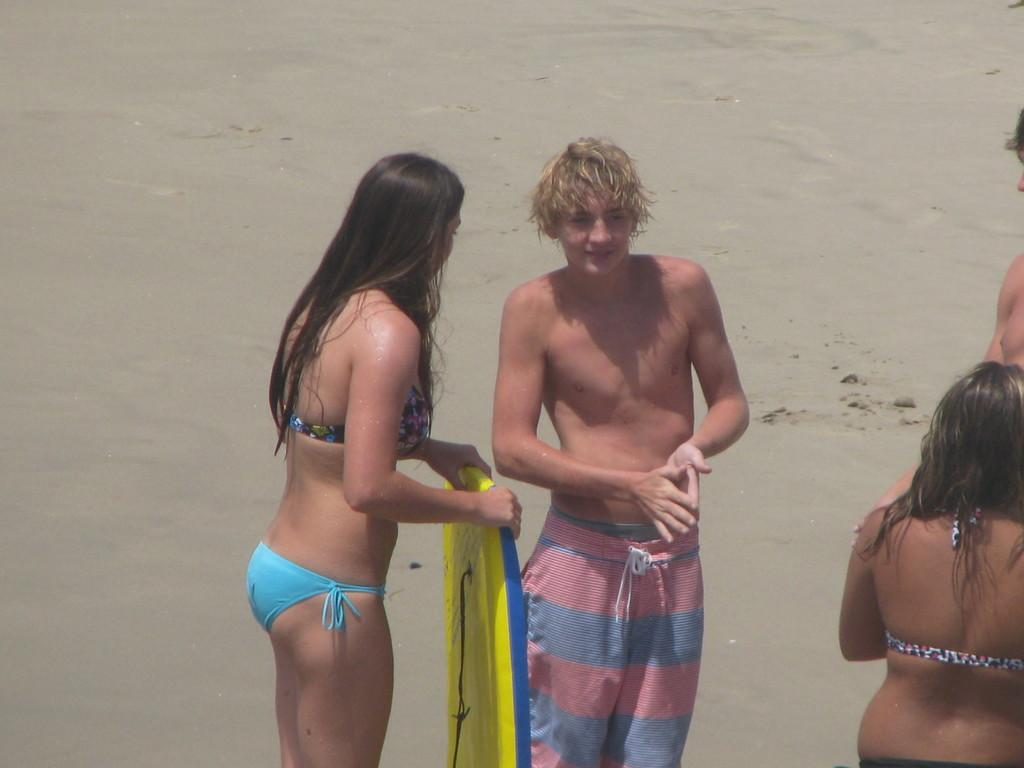How many people are in the image? There are people in the image, but the exact number is not specified. What is the lady holding in the image? A lady is holding an object in the image. What can be seen beneath the people in the image? The ground is visible in the image. What caption is written on the object the lady is holding in the image? There is no mention of a caption on the object the lady is holding in the image. What type of wrench is the lady using to teach the people in the image? There is no wrench present in the image, and the lady is not depicted as teaching anyone. 